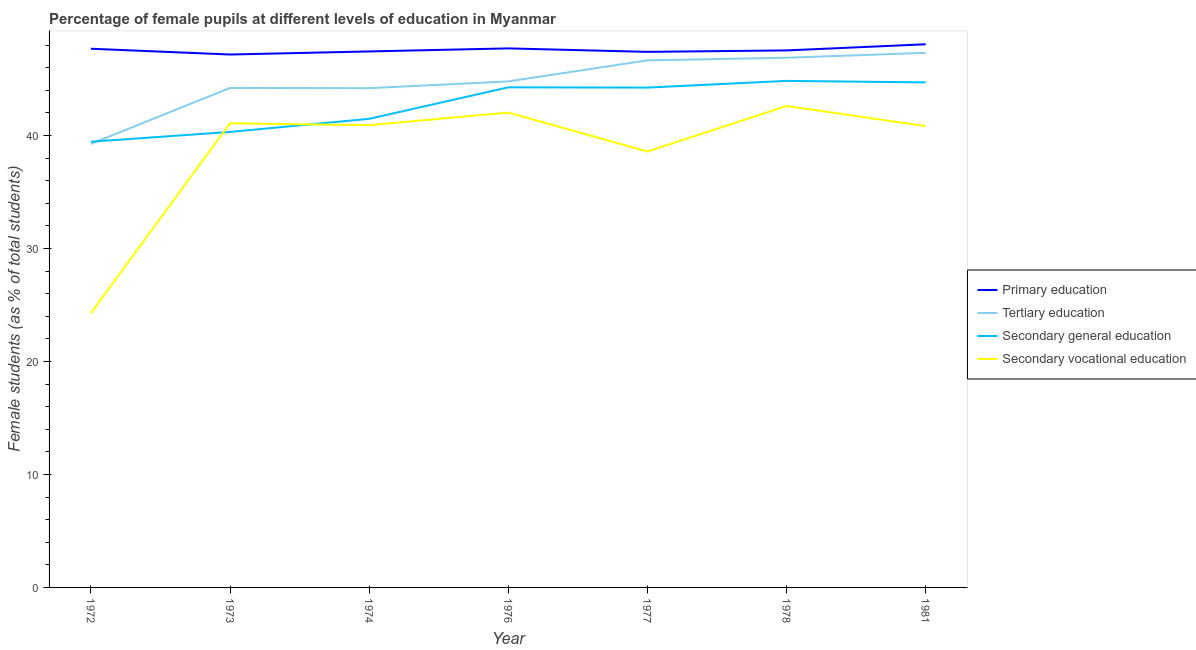How many different coloured lines are there?
Ensure brevity in your answer.  4. What is the percentage of female students in secondary vocational education in 1977?
Give a very brief answer. 38.58. Across all years, what is the maximum percentage of female students in secondary vocational education?
Make the answer very short. 42.61. Across all years, what is the minimum percentage of female students in secondary education?
Give a very brief answer. 39.45. In which year was the percentage of female students in primary education maximum?
Your response must be concise. 1981. In which year was the percentage of female students in secondary vocational education minimum?
Make the answer very short. 1972. What is the total percentage of female students in primary education in the graph?
Make the answer very short. 332.97. What is the difference between the percentage of female students in secondary vocational education in 1973 and that in 1977?
Offer a very short reply. 2.5. What is the difference between the percentage of female students in secondary vocational education in 1981 and the percentage of female students in secondary education in 1972?
Offer a terse response. 1.38. What is the average percentage of female students in primary education per year?
Ensure brevity in your answer.  47.57. In the year 1972, what is the difference between the percentage of female students in secondary vocational education and percentage of female students in tertiary education?
Offer a terse response. -14.98. What is the ratio of the percentage of female students in primary education in 1977 to that in 1978?
Ensure brevity in your answer.  1. Is the percentage of female students in primary education in 1976 less than that in 1977?
Provide a short and direct response. No. What is the difference between the highest and the second highest percentage of female students in secondary vocational education?
Your answer should be compact. 0.58. What is the difference between the highest and the lowest percentage of female students in secondary education?
Offer a very short reply. 5.38. In how many years, is the percentage of female students in secondary vocational education greater than the average percentage of female students in secondary vocational education taken over all years?
Give a very brief answer. 5. Is it the case that in every year, the sum of the percentage of female students in secondary education and percentage of female students in primary education is greater than the sum of percentage of female students in tertiary education and percentage of female students in secondary vocational education?
Provide a short and direct response. Yes. Is it the case that in every year, the sum of the percentage of female students in primary education and percentage of female students in tertiary education is greater than the percentage of female students in secondary education?
Your response must be concise. Yes. How many lines are there?
Give a very brief answer. 4. Does the graph contain any zero values?
Provide a short and direct response. No. Where does the legend appear in the graph?
Keep it short and to the point. Center right. How are the legend labels stacked?
Offer a terse response. Vertical. What is the title of the graph?
Your response must be concise. Percentage of female pupils at different levels of education in Myanmar. What is the label or title of the Y-axis?
Offer a terse response. Female students (as % of total students). What is the Female students (as % of total students) of Primary education in 1972?
Offer a terse response. 47.67. What is the Female students (as % of total students) of Tertiary education in 1972?
Offer a very short reply. 39.25. What is the Female students (as % of total students) of Secondary general education in 1972?
Provide a succinct answer. 39.45. What is the Female students (as % of total students) of Secondary vocational education in 1972?
Make the answer very short. 24.27. What is the Female students (as % of total students) in Primary education in 1973?
Your answer should be compact. 47.16. What is the Female students (as % of total students) of Tertiary education in 1973?
Your answer should be compact. 44.2. What is the Female students (as % of total students) of Secondary general education in 1973?
Your answer should be compact. 40.31. What is the Female students (as % of total students) of Secondary vocational education in 1973?
Provide a short and direct response. 41.08. What is the Female students (as % of total students) of Primary education in 1974?
Make the answer very short. 47.44. What is the Female students (as % of total students) of Tertiary education in 1974?
Ensure brevity in your answer.  44.18. What is the Female students (as % of total students) of Secondary general education in 1974?
Make the answer very short. 41.47. What is the Female students (as % of total students) in Secondary vocational education in 1974?
Your response must be concise. 40.91. What is the Female students (as % of total students) in Primary education in 1976?
Provide a short and direct response. 47.7. What is the Female students (as % of total students) in Tertiary education in 1976?
Your response must be concise. 44.78. What is the Female students (as % of total students) of Secondary general education in 1976?
Offer a very short reply. 44.26. What is the Female students (as % of total students) of Secondary vocational education in 1976?
Your response must be concise. 42.03. What is the Female students (as % of total students) in Primary education in 1977?
Keep it short and to the point. 47.4. What is the Female students (as % of total students) in Tertiary education in 1977?
Provide a short and direct response. 46.65. What is the Female students (as % of total students) in Secondary general education in 1977?
Your answer should be very brief. 44.24. What is the Female students (as % of total students) of Secondary vocational education in 1977?
Keep it short and to the point. 38.58. What is the Female students (as % of total students) of Primary education in 1978?
Provide a succinct answer. 47.53. What is the Female students (as % of total students) in Tertiary education in 1978?
Your response must be concise. 46.87. What is the Female students (as % of total students) in Secondary general education in 1978?
Provide a short and direct response. 44.83. What is the Female students (as % of total students) of Secondary vocational education in 1978?
Offer a very short reply. 42.61. What is the Female students (as % of total students) of Primary education in 1981?
Your response must be concise. 48.07. What is the Female students (as % of total students) in Tertiary education in 1981?
Your answer should be very brief. 47.31. What is the Female students (as % of total students) in Secondary general education in 1981?
Give a very brief answer. 44.69. What is the Female students (as % of total students) in Secondary vocational education in 1981?
Your answer should be very brief. 40.83. Across all years, what is the maximum Female students (as % of total students) of Primary education?
Offer a terse response. 48.07. Across all years, what is the maximum Female students (as % of total students) in Tertiary education?
Provide a short and direct response. 47.31. Across all years, what is the maximum Female students (as % of total students) of Secondary general education?
Provide a succinct answer. 44.83. Across all years, what is the maximum Female students (as % of total students) of Secondary vocational education?
Your answer should be very brief. 42.61. Across all years, what is the minimum Female students (as % of total students) in Primary education?
Offer a terse response. 47.16. Across all years, what is the minimum Female students (as % of total students) in Tertiary education?
Provide a short and direct response. 39.25. Across all years, what is the minimum Female students (as % of total students) of Secondary general education?
Make the answer very short. 39.45. Across all years, what is the minimum Female students (as % of total students) of Secondary vocational education?
Make the answer very short. 24.27. What is the total Female students (as % of total students) in Primary education in the graph?
Ensure brevity in your answer.  332.97. What is the total Female students (as % of total students) of Tertiary education in the graph?
Your answer should be compact. 313.26. What is the total Female students (as % of total students) of Secondary general education in the graph?
Your answer should be very brief. 299.25. What is the total Female students (as % of total students) of Secondary vocational education in the graph?
Offer a terse response. 270.3. What is the difference between the Female students (as % of total students) of Primary education in 1972 and that in 1973?
Your response must be concise. 0.51. What is the difference between the Female students (as % of total students) in Tertiary education in 1972 and that in 1973?
Your answer should be very brief. -4.95. What is the difference between the Female students (as % of total students) of Secondary general education in 1972 and that in 1973?
Your answer should be compact. -0.86. What is the difference between the Female students (as % of total students) in Secondary vocational education in 1972 and that in 1973?
Offer a terse response. -16.81. What is the difference between the Female students (as % of total students) of Primary education in 1972 and that in 1974?
Your answer should be compact. 0.24. What is the difference between the Female students (as % of total students) in Tertiary education in 1972 and that in 1974?
Give a very brief answer. -4.93. What is the difference between the Female students (as % of total students) of Secondary general education in 1972 and that in 1974?
Your response must be concise. -2.02. What is the difference between the Female students (as % of total students) of Secondary vocational education in 1972 and that in 1974?
Provide a succinct answer. -16.64. What is the difference between the Female students (as % of total students) in Primary education in 1972 and that in 1976?
Keep it short and to the point. -0.03. What is the difference between the Female students (as % of total students) in Tertiary education in 1972 and that in 1976?
Give a very brief answer. -5.53. What is the difference between the Female students (as % of total students) of Secondary general education in 1972 and that in 1976?
Your answer should be very brief. -4.81. What is the difference between the Female students (as % of total students) in Secondary vocational education in 1972 and that in 1976?
Your response must be concise. -17.75. What is the difference between the Female students (as % of total students) in Primary education in 1972 and that in 1977?
Your answer should be very brief. 0.28. What is the difference between the Female students (as % of total students) of Tertiary education in 1972 and that in 1977?
Your response must be concise. -7.39. What is the difference between the Female students (as % of total students) of Secondary general education in 1972 and that in 1977?
Your answer should be very brief. -4.79. What is the difference between the Female students (as % of total students) of Secondary vocational education in 1972 and that in 1977?
Ensure brevity in your answer.  -14.31. What is the difference between the Female students (as % of total students) in Primary education in 1972 and that in 1978?
Ensure brevity in your answer.  0.15. What is the difference between the Female students (as % of total students) in Tertiary education in 1972 and that in 1978?
Keep it short and to the point. -7.62. What is the difference between the Female students (as % of total students) of Secondary general education in 1972 and that in 1978?
Keep it short and to the point. -5.38. What is the difference between the Female students (as % of total students) in Secondary vocational education in 1972 and that in 1978?
Keep it short and to the point. -18.33. What is the difference between the Female students (as % of total students) of Primary education in 1972 and that in 1981?
Your answer should be very brief. -0.4. What is the difference between the Female students (as % of total students) of Tertiary education in 1972 and that in 1981?
Provide a succinct answer. -8.06. What is the difference between the Female students (as % of total students) in Secondary general education in 1972 and that in 1981?
Your response must be concise. -5.25. What is the difference between the Female students (as % of total students) of Secondary vocational education in 1972 and that in 1981?
Your answer should be compact. -16.55. What is the difference between the Female students (as % of total students) in Primary education in 1973 and that in 1974?
Offer a very short reply. -0.27. What is the difference between the Female students (as % of total students) of Tertiary education in 1973 and that in 1974?
Provide a short and direct response. 0.02. What is the difference between the Female students (as % of total students) of Secondary general education in 1973 and that in 1974?
Provide a short and direct response. -1.16. What is the difference between the Female students (as % of total students) in Secondary vocational education in 1973 and that in 1974?
Provide a short and direct response. 0.17. What is the difference between the Female students (as % of total students) in Primary education in 1973 and that in 1976?
Provide a short and direct response. -0.54. What is the difference between the Female students (as % of total students) in Tertiary education in 1973 and that in 1976?
Your response must be concise. -0.58. What is the difference between the Female students (as % of total students) of Secondary general education in 1973 and that in 1976?
Keep it short and to the point. -3.95. What is the difference between the Female students (as % of total students) in Secondary vocational education in 1973 and that in 1976?
Keep it short and to the point. -0.95. What is the difference between the Female students (as % of total students) in Primary education in 1973 and that in 1977?
Your response must be concise. -0.24. What is the difference between the Female students (as % of total students) of Tertiary education in 1973 and that in 1977?
Your answer should be very brief. -2.44. What is the difference between the Female students (as % of total students) in Secondary general education in 1973 and that in 1977?
Provide a short and direct response. -3.93. What is the difference between the Female students (as % of total students) in Secondary vocational education in 1973 and that in 1977?
Provide a succinct answer. 2.5. What is the difference between the Female students (as % of total students) in Primary education in 1973 and that in 1978?
Give a very brief answer. -0.36. What is the difference between the Female students (as % of total students) of Tertiary education in 1973 and that in 1978?
Your answer should be compact. -2.67. What is the difference between the Female students (as % of total students) in Secondary general education in 1973 and that in 1978?
Give a very brief answer. -4.52. What is the difference between the Female students (as % of total students) of Secondary vocational education in 1973 and that in 1978?
Give a very brief answer. -1.53. What is the difference between the Female students (as % of total students) of Primary education in 1973 and that in 1981?
Your response must be concise. -0.91. What is the difference between the Female students (as % of total students) of Tertiary education in 1973 and that in 1981?
Make the answer very short. -3.11. What is the difference between the Female students (as % of total students) of Secondary general education in 1973 and that in 1981?
Provide a short and direct response. -4.38. What is the difference between the Female students (as % of total students) in Secondary vocational education in 1973 and that in 1981?
Make the answer very short. 0.25. What is the difference between the Female students (as % of total students) in Primary education in 1974 and that in 1976?
Offer a very short reply. -0.27. What is the difference between the Female students (as % of total students) of Tertiary education in 1974 and that in 1976?
Your answer should be compact. -0.6. What is the difference between the Female students (as % of total students) in Secondary general education in 1974 and that in 1976?
Keep it short and to the point. -2.79. What is the difference between the Female students (as % of total students) of Secondary vocational education in 1974 and that in 1976?
Offer a terse response. -1.12. What is the difference between the Female students (as % of total students) in Primary education in 1974 and that in 1977?
Provide a succinct answer. 0.04. What is the difference between the Female students (as % of total students) in Tertiary education in 1974 and that in 1977?
Make the answer very short. -2.46. What is the difference between the Female students (as % of total students) of Secondary general education in 1974 and that in 1977?
Provide a succinct answer. -2.77. What is the difference between the Female students (as % of total students) in Secondary vocational education in 1974 and that in 1977?
Ensure brevity in your answer.  2.33. What is the difference between the Female students (as % of total students) of Primary education in 1974 and that in 1978?
Ensure brevity in your answer.  -0.09. What is the difference between the Female students (as % of total students) of Tertiary education in 1974 and that in 1978?
Make the answer very short. -2.69. What is the difference between the Female students (as % of total students) of Secondary general education in 1974 and that in 1978?
Provide a succinct answer. -3.36. What is the difference between the Female students (as % of total students) in Secondary vocational education in 1974 and that in 1978?
Offer a terse response. -1.7. What is the difference between the Female students (as % of total students) in Primary education in 1974 and that in 1981?
Keep it short and to the point. -0.63. What is the difference between the Female students (as % of total students) in Tertiary education in 1974 and that in 1981?
Your response must be concise. -3.13. What is the difference between the Female students (as % of total students) of Secondary general education in 1974 and that in 1981?
Ensure brevity in your answer.  -3.22. What is the difference between the Female students (as % of total students) of Secondary vocational education in 1974 and that in 1981?
Your response must be concise. 0.08. What is the difference between the Female students (as % of total students) of Primary education in 1976 and that in 1977?
Give a very brief answer. 0.31. What is the difference between the Female students (as % of total students) of Tertiary education in 1976 and that in 1977?
Give a very brief answer. -1.86. What is the difference between the Female students (as % of total students) in Secondary general education in 1976 and that in 1977?
Give a very brief answer. 0.02. What is the difference between the Female students (as % of total students) in Secondary vocational education in 1976 and that in 1977?
Keep it short and to the point. 3.45. What is the difference between the Female students (as % of total students) of Primary education in 1976 and that in 1978?
Ensure brevity in your answer.  0.18. What is the difference between the Female students (as % of total students) of Tertiary education in 1976 and that in 1978?
Give a very brief answer. -2.09. What is the difference between the Female students (as % of total students) of Secondary general education in 1976 and that in 1978?
Ensure brevity in your answer.  -0.57. What is the difference between the Female students (as % of total students) in Secondary vocational education in 1976 and that in 1978?
Provide a short and direct response. -0.58. What is the difference between the Female students (as % of total students) in Primary education in 1976 and that in 1981?
Your answer should be very brief. -0.37. What is the difference between the Female students (as % of total students) of Tertiary education in 1976 and that in 1981?
Ensure brevity in your answer.  -2.53. What is the difference between the Female students (as % of total students) in Secondary general education in 1976 and that in 1981?
Keep it short and to the point. -0.44. What is the difference between the Female students (as % of total students) of Secondary vocational education in 1976 and that in 1981?
Provide a short and direct response. 1.2. What is the difference between the Female students (as % of total students) in Primary education in 1977 and that in 1978?
Your answer should be very brief. -0.13. What is the difference between the Female students (as % of total students) in Tertiary education in 1977 and that in 1978?
Give a very brief answer. -0.23. What is the difference between the Female students (as % of total students) of Secondary general education in 1977 and that in 1978?
Provide a short and direct response. -0.59. What is the difference between the Female students (as % of total students) of Secondary vocational education in 1977 and that in 1978?
Provide a short and direct response. -4.03. What is the difference between the Female students (as % of total students) of Primary education in 1977 and that in 1981?
Your answer should be compact. -0.67. What is the difference between the Female students (as % of total students) in Tertiary education in 1977 and that in 1981?
Your response must be concise. -0.66. What is the difference between the Female students (as % of total students) of Secondary general education in 1977 and that in 1981?
Your answer should be very brief. -0.46. What is the difference between the Female students (as % of total students) of Secondary vocational education in 1977 and that in 1981?
Give a very brief answer. -2.25. What is the difference between the Female students (as % of total students) in Primary education in 1978 and that in 1981?
Offer a terse response. -0.54. What is the difference between the Female students (as % of total students) in Tertiary education in 1978 and that in 1981?
Ensure brevity in your answer.  -0.44. What is the difference between the Female students (as % of total students) of Secondary general education in 1978 and that in 1981?
Ensure brevity in your answer.  0.13. What is the difference between the Female students (as % of total students) in Secondary vocational education in 1978 and that in 1981?
Provide a succinct answer. 1.78. What is the difference between the Female students (as % of total students) in Primary education in 1972 and the Female students (as % of total students) in Tertiary education in 1973?
Provide a short and direct response. 3.47. What is the difference between the Female students (as % of total students) in Primary education in 1972 and the Female students (as % of total students) in Secondary general education in 1973?
Your answer should be compact. 7.36. What is the difference between the Female students (as % of total students) of Primary education in 1972 and the Female students (as % of total students) of Secondary vocational education in 1973?
Your answer should be very brief. 6.6. What is the difference between the Female students (as % of total students) in Tertiary education in 1972 and the Female students (as % of total students) in Secondary general education in 1973?
Ensure brevity in your answer.  -1.06. What is the difference between the Female students (as % of total students) in Tertiary education in 1972 and the Female students (as % of total students) in Secondary vocational education in 1973?
Provide a short and direct response. -1.83. What is the difference between the Female students (as % of total students) in Secondary general education in 1972 and the Female students (as % of total students) in Secondary vocational education in 1973?
Your response must be concise. -1.63. What is the difference between the Female students (as % of total students) in Primary education in 1972 and the Female students (as % of total students) in Tertiary education in 1974?
Provide a short and direct response. 3.49. What is the difference between the Female students (as % of total students) in Primary education in 1972 and the Female students (as % of total students) in Secondary general education in 1974?
Offer a very short reply. 6.2. What is the difference between the Female students (as % of total students) of Primary education in 1972 and the Female students (as % of total students) of Secondary vocational education in 1974?
Provide a short and direct response. 6.76. What is the difference between the Female students (as % of total students) in Tertiary education in 1972 and the Female students (as % of total students) in Secondary general education in 1974?
Offer a very short reply. -2.22. What is the difference between the Female students (as % of total students) of Tertiary education in 1972 and the Female students (as % of total students) of Secondary vocational education in 1974?
Your response must be concise. -1.66. What is the difference between the Female students (as % of total students) in Secondary general education in 1972 and the Female students (as % of total students) in Secondary vocational education in 1974?
Offer a terse response. -1.46. What is the difference between the Female students (as % of total students) in Primary education in 1972 and the Female students (as % of total students) in Tertiary education in 1976?
Ensure brevity in your answer.  2.89. What is the difference between the Female students (as % of total students) of Primary education in 1972 and the Female students (as % of total students) of Secondary general education in 1976?
Your answer should be very brief. 3.42. What is the difference between the Female students (as % of total students) of Primary education in 1972 and the Female students (as % of total students) of Secondary vocational education in 1976?
Offer a terse response. 5.65. What is the difference between the Female students (as % of total students) of Tertiary education in 1972 and the Female students (as % of total students) of Secondary general education in 1976?
Offer a terse response. -5. What is the difference between the Female students (as % of total students) of Tertiary education in 1972 and the Female students (as % of total students) of Secondary vocational education in 1976?
Your response must be concise. -2.77. What is the difference between the Female students (as % of total students) of Secondary general education in 1972 and the Female students (as % of total students) of Secondary vocational education in 1976?
Offer a terse response. -2.58. What is the difference between the Female students (as % of total students) in Primary education in 1972 and the Female students (as % of total students) in Tertiary education in 1977?
Keep it short and to the point. 1.03. What is the difference between the Female students (as % of total students) of Primary education in 1972 and the Female students (as % of total students) of Secondary general education in 1977?
Ensure brevity in your answer.  3.44. What is the difference between the Female students (as % of total students) in Primary education in 1972 and the Female students (as % of total students) in Secondary vocational education in 1977?
Offer a very short reply. 9.1. What is the difference between the Female students (as % of total students) of Tertiary education in 1972 and the Female students (as % of total students) of Secondary general education in 1977?
Ensure brevity in your answer.  -4.98. What is the difference between the Female students (as % of total students) of Tertiary education in 1972 and the Female students (as % of total students) of Secondary vocational education in 1977?
Your answer should be compact. 0.67. What is the difference between the Female students (as % of total students) in Secondary general education in 1972 and the Female students (as % of total students) in Secondary vocational education in 1977?
Your response must be concise. 0.87. What is the difference between the Female students (as % of total students) of Primary education in 1972 and the Female students (as % of total students) of Tertiary education in 1978?
Provide a succinct answer. 0.8. What is the difference between the Female students (as % of total students) in Primary education in 1972 and the Female students (as % of total students) in Secondary general education in 1978?
Provide a succinct answer. 2.85. What is the difference between the Female students (as % of total students) of Primary education in 1972 and the Female students (as % of total students) of Secondary vocational education in 1978?
Your answer should be compact. 5.07. What is the difference between the Female students (as % of total students) of Tertiary education in 1972 and the Female students (as % of total students) of Secondary general education in 1978?
Ensure brevity in your answer.  -5.58. What is the difference between the Female students (as % of total students) of Tertiary education in 1972 and the Female students (as % of total students) of Secondary vocational education in 1978?
Offer a very short reply. -3.35. What is the difference between the Female students (as % of total students) of Secondary general education in 1972 and the Female students (as % of total students) of Secondary vocational education in 1978?
Offer a terse response. -3.16. What is the difference between the Female students (as % of total students) of Primary education in 1972 and the Female students (as % of total students) of Tertiary education in 1981?
Make the answer very short. 0.36. What is the difference between the Female students (as % of total students) in Primary education in 1972 and the Female students (as % of total students) in Secondary general education in 1981?
Provide a short and direct response. 2.98. What is the difference between the Female students (as % of total students) of Primary education in 1972 and the Female students (as % of total students) of Secondary vocational education in 1981?
Ensure brevity in your answer.  6.85. What is the difference between the Female students (as % of total students) in Tertiary education in 1972 and the Female students (as % of total students) in Secondary general education in 1981?
Offer a terse response. -5.44. What is the difference between the Female students (as % of total students) in Tertiary education in 1972 and the Female students (as % of total students) in Secondary vocational education in 1981?
Keep it short and to the point. -1.57. What is the difference between the Female students (as % of total students) in Secondary general education in 1972 and the Female students (as % of total students) in Secondary vocational education in 1981?
Provide a short and direct response. -1.38. What is the difference between the Female students (as % of total students) in Primary education in 1973 and the Female students (as % of total students) in Tertiary education in 1974?
Offer a very short reply. 2.98. What is the difference between the Female students (as % of total students) of Primary education in 1973 and the Female students (as % of total students) of Secondary general education in 1974?
Your response must be concise. 5.69. What is the difference between the Female students (as % of total students) in Primary education in 1973 and the Female students (as % of total students) in Secondary vocational education in 1974?
Offer a very short reply. 6.25. What is the difference between the Female students (as % of total students) in Tertiary education in 1973 and the Female students (as % of total students) in Secondary general education in 1974?
Your answer should be compact. 2.73. What is the difference between the Female students (as % of total students) in Tertiary education in 1973 and the Female students (as % of total students) in Secondary vocational education in 1974?
Give a very brief answer. 3.29. What is the difference between the Female students (as % of total students) of Secondary general education in 1973 and the Female students (as % of total students) of Secondary vocational education in 1974?
Give a very brief answer. -0.6. What is the difference between the Female students (as % of total students) in Primary education in 1973 and the Female students (as % of total students) in Tertiary education in 1976?
Offer a very short reply. 2.38. What is the difference between the Female students (as % of total students) of Primary education in 1973 and the Female students (as % of total students) of Secondary general education in 1976?
Provide a succinct answer. 2.9. What is the difference between the Female students (as % of total students) of Primary education in 1973 and the Female students (as % of total students) of Secondary vocational education in 1976?
Provide a short and direct response. 5.14. What is the difference between the Female students (as % of total students) in Tertiary education in 1973 and the Female students (as % of total students) in Secondary general education in 1976?
Provide a short and direct response. -0.05. What is the difference between the Female students (as % of total students) of Tertiary education in 1973 and the Female students (as % of total students) of Secondary vocational education in 1976?
Provide a succinct answer. 2.18. What is the difference between the Female students (as % of total students) of Secondary general education in 1973 and the Female students (as % of total students) of Secondary vocational education in 1976?
Offer a terse response. -1.71. What is the difference between the Female students (as % of total students) of Primary education in 1973 and the Female students (as % of total students) of Tertiary education in 1977?
Your answer should be very brief. 0.52. What is the difference between the Female students (as % of total students) of Primary education in 1973 and the Female students (as % of total students) of Secondary general education in 1977?
Your answer should be compact. 2.93. What is the difference between the Female students (as % of total students) in Primary education in 1973 and the Female students (as % of total students) in Secondary vocational education in 1977?
Your response must be concise. 8.58. What is the difference between the Female students (as % of total students) of Tertiary education in 1973 and the Female students (as % of total students) of Secondary general education in 1977?
Ensure brevity in your answer.  -0.03. What is the difference between the Female students (as % of total students) of Tertiary education in 1973 and the Female students (as % of total students) of Secondary vocational education in 1977?
Offer a terse response. 5.63. What is the difference between the Female students (as % of total students) in Secondary general education in 1973 and the Female students (as % of total students) in Secondary vocational education in 1977?
Provide a short and direct response. 1.73. What is the difference between the Female students (as % of total students) of Primary education in 1973 and the Female students (as % of total students) of Tertiary education in 1978?
Make the answer very short. 0.29. What is the difference between the Female students (as % of total students) of Primary education in 1973 and the Female students (as % of total students) of Secondary general education in 1978?
Give a very brief answer. 2.33. What is the difference between the Female students (as % of total students) of Primary education in 1973 and the Female students (as % of total students) of Secondary vocational education in 1978?
Make the answer very short. 4.56. What is the difference between the Female students (as % of total students) of Tertiary education in 1973 and the Female students (as % of total students) of Secondary general education in 1978?
Provide a short and direct response. -0.62. What is the difference between the Female students (as % of total students) of Tertiary education in 1973 and the Female students (as % of total students) of Secondary vocational education in 1978?
Provide a succinct answer. 1.6. What is the difference between the Female students (as % of total students) in Secondary general education in 1973 and the Female students (as % of total students) in Secondary vocational education in 1978?
Ensure brevity in your answer.  -2.29. What is the difference between the Female students (as % of total students) of Primary education in 1973 and the Female students (as % of total students) of Tertiary education in 1981?
Your response must be concise. -0.15. What is the difference between the Female students (as % of total students) of Primary education in 1973 and the Female students (as % of total students) of Secondary general education in 1981?
Keep it short and to the point. 2.47. What is the difference between the Female students (as % of total students) in Primary education in 1973 and the Female students (as % of total students) in Secondary vocational education in 1981?
Your answer should be very brief. 6.34. What is the difference between the Female students (as % of total students) in Tertiary education in 1973 and the Female students (as % of total students) in Secondary general education in 1981?
Make the answer very short. -0.49. What is the difference between the Female students (as % of total students) in Tertiary education in 1973 and the Female students (as % of total students) in Secondary vocational education in 1981?
Provide a succinct answer. 3.38. What is the difference between the Female students (as % of total students) of Secondary general education in 1973 and the Female students (as % of total students) of Secondary vocational education in 1981?
Offer a very short reply. -0.52. What is the difference between the Female students (as % of total students) in Primary education in 1974 and the Female students (as % of total students) in Tertiary education in 1976?
Give a very brief answer. 2.65. What is the difference between the Female students (as % of total students) in Primary education in 1974 and the Female students (as % of total students) in Secondary general education in 1976?
Your answer should be compact. 3.18. What is the difference between the Female students (as % of total students) in Primary education in 1974 and the Female students (as % of total students) in Secondary vocational education in 1976?
Give a very brief answer. 5.41. What is the difference between the Female students (as % of total students) in Tertiary education in 1974 and the Female students (as % of total students) in Secondary general education in 1976?
Your response must be concise. -0.07. What is the difference between the Female students (as % of total students) of Tertiary education in 1974 and the Female students (as % of total students) of Secondary vocational education in 1976?
Your answer should be compact. 2.16. What is the difference between the Female students (as % of total students) in Secondary general education in 1974 and the Female students (as % of total students) in Secondary vocational education in 1976?
Your answer should be compact. -0.55. What is the difference between the Female students (as % of total students) in Primary education in 1974 and the Female students (as % of total students) in Tertiary education in 1977?
Offer a terse response. 0.79. What is the difference between the Female students (as % of total students) of Primary education in 1974 and the Female students (as % of total students) of Secondary general education in 1977?
Provide a short and direct response. 3.2. What is the difference between the Female students (as % of total students) of Primary education in 1974 and the Female students (as % of total students) of Secondary vocational education in 1977?
Your answer should be very brief. 8.86. What is the difference between the Female students (as % of total students) of Tertiary education in 1974 and the Female students (as % of total students) of Secondary general education in 1977?
Provide a succinct answer. -0.05. What is the difference between the Female students (as % of total students) of Tertiary education in 1974 and the Female students (as % of total students) of Secondary vocational education in 1977?
Give a very brief answer. 5.61. What is the difference between the Female students (as % of total students) of Secondary general education in 1974 and the Female students (as % of total students) of Secondary vocational education in 1977?
Provide a succinct answer. 2.89. What is the difference between the Female students (as % of total students) of Primary education in 1974 and the Female students (as % of total students) of Tertiary education in 1978?
Offer a terse response. 0.56. What is the difference between the Female students (as % of total students) of Primary education in 1974 and the Female students (as % of total students) of Secondary general education in 1978?
Offer a terse response. 2.61. What is the difference between the Female students (as % of total students) in Primary education in 1974 and the Female students (as % of total students) in Secondary vocational education in 1978?
Keep it short and to the point. 4.83. What is the difference between the Female students (as % of total students) in Tertiary education in 1974 and the Female students (as % of total students) in Secondary general education in 1978?
Provide a short and direct response. -0.65. What is the difference between the Female students (as % of total students) of Tertiary education in 1974 and the Female students (as % of total students) of Secondary vocational education in 1978?
Ensure brevity in your answer.  1.58. What is the difference between the Female students (as % of total students) of Secondary general education in 1974 and the Female students (as % of total students) of Secondary vocational education in 1978?
Your response must be concise. -1.13. What is the difference between the Female students (as % of total students) of Primary education in 1974 and the Female students (as % of total students) of Tertiary education in 1981?
Your answer should be compact. 0.12. What is the difference between the Female students (as % of total students) of Primary education in 1974 and the Female students (as % of total students) of Secondary general education in 1981?
Your answer should be compact. 2.74. What is the difference between the Female students (as % of total students) in Primary education in 1974 and the Female students (as % of total students) in Secondary vocational education in 1981?
Your answer should be very brief. 6.61. What is the difference between the Female students (as % of total students) in Tertiary education in 1974 and the Female students (as % of total students) in Secondary general education in 1981?
Keep it short and to the point. -0.51. What is the difference between the Female students (as % of total students) of Tertiary education in 1974 and the Female students (as % of total students) of Secondary vocational education in 1981?
Ensure brevity in your answer.  3.36. What is the difference between the Female students (as % of total students) of Secondary general education in 1974 and the Female students (as % of total students) of Secondary vocational education in 1981?
Provide a short and direct response. 0.64. What is the difference between the Female students (as % of total students) in Primary education in 1976 and the Female students (as % of total students) in Tertiary education in 1977?
Make the answer very short. 1.06. What is the difference between the Female students (as % of total students) of Primary education in 1976 and the Female students (as % of total students) of Secondary general education in 1977?
Offer a very short reply. 3.47. What is the difference between the Female students (as % of total students) in Primary education in 1976 and the Female students (as % of total students) in Secondary vocational education in 1977?
Keep it short and to the point. 9.13. What is the difference between the Female students (as % of total students) of Tertiary education in 1976 and the Female students (as % of total students) of Secondary general education in 1977?
Keep it short and to the point. 0.55. What is the difference between the Female students (as % of total students) in Tertiary education in 1976 and the Female students (as % of total students) in Secondary vocational education in 1977?
Ensure brevity in your answer.  6.2. What is the difference between the Female students (as % of total students) in Secondary general education in 1976 and the Female students (as % of total students) in Secondary vocational education in 1977?
Your answer should be very brief. 5.68. What is the difference between the Female students (as % of total students) of Primary education in 1976 and the Female students (as % of total students) of Tertiary education in 1978?
Offer a very short reply. 0.83. What is the difference between the Female students (as % of total students) in Primary education in 1976 and the Female students (as % of total students) in Secondary general education in 1978?
Offer a very short reply. 2.88. What is the difference between the Female students (as % of total students) in Primary education in 1976 and the Female students (as % of total students) in Secondary vocational education in 1978?
Your response must be concise. 5.1. What is the difference between the Female students (as % of total students) in Tertiary education in 1976 and the Female students (as % of total students) in Secondary general education in 1978?
Your answer should be very brief. -0.05. What is the difference between the Female students (as % of total students) in Tertiary education in 1976 and the Female students (as % of total students) in Secondary vocational education in 1978?
Provide a short and direct response. 2.18. What is the difference between the Female students (as % of total students) in Secondary general education in 1976 and the Female students (as % of total students) in Secondary vocational education in 1978?
Make the answer very short. 1.65. What is the difference between the Female students (as % of total students) in Primary education in 1976 and the Female students (as % of total students) in Tertiary education in 1981?
Offer a terse response. 0.39. What is the difference between the Female students (as % of total students) in Primary education in 1976 and the Female students (as % of total students) in Secondary general education in 1981?
Your answer should be very brief. 3.01. What is the difference between the Female students (as % of total students) of Primary education in 1976 and the Female students (as % of total students) of Secondary vocational education in 1981?
Offer a terse response. 6.88. What is the difference between the Female students (as % of total students) in Tertiary education in 1976 and the Female students (as % of total students) in Secondary general education in 1981?
Your answer should be compact. 0.09. What is the difference between the Female students (as % of total students) in Tertiary education in 1976 and the Female students (as % of total students) in Secondary vocational education in 1981?
Ensure brevity in your answer.  3.96. What is the difference between the Female students (as % of total students) in Secondary general education in 1976 and the Female students (as % of total students) in Secondary vocational education in 1981?
Your response must be concise. 3.43. What is the difference between the Female students (as % of total students) in Primary education in 1977 and the Female students (as % of total students) in Tertiary education in 1978?
Give a very brief answer. 0.52. What is the difference between the Female students (as % of total students) in Primary education in 1977 and the Female students (as % of total students) in Secondary general education in 1978?
Keep it short and to the point. 2.57. What is the difference between the Female students (as % of total students) in Primary education in 1977 and the Female students (as % of total students) in Secondary vocational education in 1978?
Offer a terse response. 4.79. What is the difference between the Female students (as % of total students) in Tertiary education in 1977 and the Female students (as % of total students) in Secondary general education in 1978?
Provide a short and direct response. 1.82. What is the difference between the Female students (as % of total students) of Tertiary education in 1977 and the Female students (as % of total students) of Secondary vocational education in 1978?
Your answer should be very brief. 4.04. What is the difference between the Female students (as % of total students) of Secondary general education in 1977 and the Female students (as % of total students) of Secondary vocational education in 1978?
Ensure brevity in your answer.  1.63. What is the difference between the Female students (as % of total students) of Primary education in 1977 and the Female students (as % of total students) of Tertiary education in 1981?
Give a very brief answer. 0.09. What is the difference between the Female students (as % of total students) of Primary education in 1977 and the Female students (as % of total students) of Secondary general education in 1981?
Your answer should be very brief. 2.7. What is the difference between the Female students (as % of total students) in Primary education in 1977 and the Female students (as % of total students) in Secondary vocational education in 1981?
Provide a succinct answer. 6.57. What is the difference between the Female students (as % of total students) in Tertiary education in 1977 and the Female students (as % of total students) in Secondary general education in 1981?
Offer a terse response. 1.95. What is the difference between the Female students (as % of total students) in Tertiary education in 1977 and the Female students (as % of total students) in Secondary vocational education in 1981?
Make the answer very short. 5.82. What is the difference between the Female students (as % of total students) in Secondary general education in 1977 and the Female students (as % of total students) in Secondary vocational education in 1981?
Offer a terse response. 3.41. What is the difference between the Female students (as % of total students) in Primary education in 1978 and the Female students (as % of total students) in Tertiary education in 1981?
Provide a short and direct response. 0.21. What is the difference between the Female students (as % of total students) in Primary education in 1978 and the Female students (as % of total students) in Secondary general education in 1981?
Provide a short and direct response. 2.83. What is the difference between the Female students (as % of total students) of Primary education in 1978 and the Female students (as % of total students) of Secondary vocational education in 1981?
Give a very brief answer. 6.7. What is the difference between the Female students (as % of total students) in Tertiary education in 1978 and the Female students (as % of total students) in Secondary general education in 1981?
Offer a terse response. 2.18. What is the difference between the Female students (as % of total students) in Tertiary education in 1978 and the Female students (as % of total students) in Secondary vocational education in 1981?
Offer a very short reply. 6.05. What is the difference between the Female students (as % of total students) in Secondary general education in 1978 and the Female students (as % of total students) in Secondary vocational education in 1981?
Give a very brief answer. 4. What is the average Female students (as % of total students) in Primary education per year?
Give a very brief answer. 47.57. What is the average Female students (as % of total students) in Tertiary education per year?
Your answer should be very brief. 44.75. What is the average Female students (as % of total students) in Secondary general education per year?
Your answer should be very brief. 42.75. What is the average Female students (as % of total students) in Secondary vocational education per year?
Provide a short and direct response. 38.61. In the year 1972, what is the difference between the Female students (as % of total students) of Primary education and Female students (as % of total students) of Tertiary education?
Provide a short and direct response. 8.42. In the year 1972, what is the difference between the Female students (as % of total students) of Primary education and Female students (as % of total students) of Secondary general education?
Your answer should be very brief. 8.23. In the year 1972, what is the difference between the Female students (as % of total students) of Primary education and Female students (as % of total students) of Secondary vocational education?
Your answer should be very brief. 23.4. In the year 1972, what is the difference between the Female students (as % of total students) in Tertiary education and Female students (as % of total students) in Secondary general education?
Make the answer very short. -0.19. In the year 1972, what is the difference between the Female students (as % of total students) in Tertiary education and Female students (as % of total students) in Secondary vocational education?
Offer a terse response. 14.98. In the year 1972, what is the difference between the Female students (as % of total students) in Secondary general education and Female students (as % of total students) in Secondary vocational education?
Provide a succinct answer. 15.18. In the year 1973, what is the difference between the Female students (as % of total students) in Primary education and Female students (as % of total students) in Tertiary education?
Make the answer very short. 2.96. In the year 1973, what is the difference between the Female students (as % of total students) of Primary education and Female students (as % of total students) of Secondary general education?
Your answer should be very brief. 6.85. In the year 1973, what is the difference between the Female students (as % of total students) of Primary education and Female students (as % of total students) of Secondary vocational education?
Offer a very short reply. 6.08. In the year 1973, what is the difference between the Female students (as % of total students) of Tertiary education and Female students (as % of total students) of Secondary general education?
Keep it short and to the point. 3.89. In the year 1973, what is the difference between the Female students (as % of total students) in Tertiary education and Female students (as % of total students) in Secondary vocational education?
Offer a terse response. 3.13. In the year 1973, what is the difference between the Female students (as % of total students) of Secondary general education and Female students (as % of total students) of Secondary vocational education?
Provide a succinct answer. -0.77. In the year 1974, what is the difference between the Female students (as % of total students) in Primary education and Female students (as % of total students) in Tertiary education?
Your answer should be compact. 3.25. In the year 1974, what is the difference between the Female students (as % of total students) in Primary education and Female students (as % of total students) in Secondary general education?
Offer a very short reply. 5.96. In the year 1974, what is the difference between the Female students (as % of total students) of Primary education and Female students (as % of total students) of Secondary vocational education?
Make the answer very short. 6.53. In the year 1974, what is the difference between the Female students (as % of total students) in Tertiary education and Female students (as % of total students) in Secondary general education?
Your answer should be compact. 2.71. In the year 1974, what is the difference between the Female students (as % of total students) in Tertiary education and Female students (as % of total students) in Secondary vocational education?
Your answer should be very brief. 3.27. In the year 1974, what is the difference between the Female students (as % of total students) of Secondary general education and Female students (as % of total students) of Secondary vocational education?
Offer a very short reply. 0.56. In the year 1976, what is the difference between the Female students (as % of total students) in Primary education and Female students (as % of total students) in Tertiary education?
Your answer should be compact. 2.92. In the year 1976, what is the difference between the Female students (as % of total students) in Primary education and Female students (as % of total students) in Secondary general education?
Give a very brief answer. 3.45. In the year 1976, what is the difference between the Female students (as % of total students) in Primary education and Female students (as % of total students) in Secondary vocational education?
Your answer should be very brief. 5.68. In the year 1976, what is the difference between the Female students (as % of total students) of Tertiary education and Female students (as % of total students) of Secondary general education?
Ensure brevity in your answer.  0.53. In the year 1976, what is the difference between the Female students (as % of total students) of Tertiary education and Female students (as % of total students) of Secondary vocational education?
Provide a short and direct response. 2.76. In the year 1976, what is the difference between the Female students (as % of total students) of Secondary general education and Female students (as % of total students) of Secondary vocational education?
Your answer should be compact. 2.23. In the year 1977, what is the difference between the Female students (as % of total students) in Primary education and Female students (as % of total students) in Tertiary education?
Provide a succinct answer. 0.75. In the year 1977, what is the difference between the Female students (as % of total students) in Primary education and Female students (as % of total students) in Secondary general education?
Give a very brief answer. 3.16. In the year 1977, what is the difference between the Female students (as % of total students) in Primary education and Female students (as % of total students) in Secondary vocational education?
Give a very brief answer. 8.82. In the year 1977, what is the difference between the Female students (as % of total students) of Tertiary education and Female students (as % of total students) of Secondary general education?
Keep it short and to the point. 2.41. In the year 1977, what is the difference between the Female students (as % of total students) of Tertiary education and Female students (as % of total students) of Secondary vocational education?
Give a very brief answer. 8.07. In the year 1977, what is the difference between the Female students (as % of total students) of Secondary general education and Female students (as % of total students) of Secondary vocational education?
Make the answer very short. 5.66. In the year 1978, what is the difference between the Female students (as % of total students) in Primary education and Female students (as % of total students) in Tertiary education?
Give a very brief answer. 0.65. In the year 1978, what is the difference between the Female students (as % of total students) in Primary education and Female students (as % of total students) in Secondary general education?
Provide a succinct answer. 2.7. In the year 1978, what is the difference between the Female students (as % of total students) of Primary education and Female students (as % of total students) of Secondary vocational education?
Give a very brief answer. 4.92. In the year 1978, what is the difference between the Female students (as % of total students) of Tertiary education and Female students (as % of total students) of Secondary general education?
Provide a succinct answer. 2.05. In the year 1978, what is the difference between the Female students (as % of total students) of Tertiary education and Female students (as % of total students) of Secondary vocational education?
Your answer should be compact. 4.27. In the year 1978, what is the difference between the Female students (as % of total students) of Secondary general education and Female students (as % of total students) of Secondary vocational education?
Provide a succinct answer. 2.22. In the year 1981, what is the difference between the Female students (as % of total students) in Primary education and Female students (as % of total students) in Tertiary education?
Give a very brief answer. 0.76. In the year 1981, what is the difference between the Female students (as % of total students) in Primary education and Female students (as % of total students) in Secondary general education?
Give a very brief answer. 3.38. In the year 1981, what is the difference between the Female students (as % of total students) in Primary education and Female students (as % of total students) in Secondary vocational education?
Offer a terse response. 7.24. In the year 1981, what is the difference between the Female students (as % of total students) of Tertiary education and Female students (as % of total students) of Secondary general education?
Make the answer very short. 2.62. In the year 1981, what is the difference between the Female students (as % of total students) in Tertiary education and Female students (as % of total students) in Secondary vocational education?
Provide a succinct answer. 6.48. In the year 1981, what is the difference between the Female students (as % of total students) of Secondary general education and Female students (as % of total students) of Secondary vocational education?
Offer a terse response. 3.87. What is the ratio of the Female students (as % of total students) in Primary education in 1972 to that in 1973?
Ensure brevity in your answer.  1.01. What is the ratio of the Female students (as % of total students) in Tertiary education in 1972 to that in 1973?
Your response must be concise. 0.89. What is the ratio of the Female students (as % of total students) of Secondary general education in 1972 to that in 1973?
Keep it short and to the point. 0.98. What is the ratio of the Female students (as % of total students) in Secondary vocational education in 1972 to that in 1973?
Provide a short and direct response. 0.59. What is the ratio of the Female students (as % of total students) of Primary education in 1972 to that in 1974?
Offer a very short reply. 1. What is the ratio of the Female students (as % of total students) of Tertiary education in 1972 to that in 1974?
Your answer should be compact. 0.89. What is the ratio of the Female students (as % of total students) of Secondary general education in 1972 to that in 1974?
Offer a very short reply. 0.95. What is the ratio of the Female students (as % of total students) of Secondary vocational education in 1972 to that in 1974?
Ensure brevity in your answer.  0.59. What is the ratio of the Female students (as % of total students) of Primary education in 1972 to that in 1976?
Your response must be concise. 1. What is the ratio of the Female students (as % of total students) in Tertiary education in 1972 to that in 1976?
Keep it short and to the point. 0.88. What is the ratio of the Female students (as % of total students) in Secondary general education in 1972 to that in 1976?
Offer a terse response. 0.89. What is the ratio of the Female students (as % of total students) in Secondary vocational education in 1972 to that in 1976?
Ensure brevity in your answer.  0.58. What is the ratio of the Female students (as % of total students) of Tertiary education in 1972 to that in 1977?
Give a very brief answer. 0.84. What is the ratio of the Female students (as % of total students) of Secondary general education in 1972 to that in 1977?
Your answer should be compact. 0.89. What is the ratio of the Female students (as % of total students) of Secondary vocational education in 1972 to that in 1977?
Your answer should be very brief. 0.63. What is the ratio of the Female students (as % of total students) of Tertiary education in 1972 to that in 1978?
Provide a short and direct response. 0.84. What is the ratio of the Female students (as % of total students) in Secondary vocational education in 1972 to that in 1978?
Provide a short and direct response. 0.57. What is the ratio of the Female students (as % of total students) of Primary education in 1972 to that in 1981?
Provide a short and direct response. 0.99. What is the ratio of the Female students (as % of total students) in Tertiary education in 1972 to that in 1981?
Make the answer very short. 0.83. What is the ratio of the Female students (as % of total students) in Secondary general education in 1972 to that in 1981?
Offer a very short reply. 0.88. What is the ratio of the Female students (as % of total students) in Secondary vocational education in 1972 to that in 1981?
Your answer should be compact. 0.59. What is the ratio of the Female students (as % of total students) of Tertiary education in 1973 to that in 1974?
Your answer should be very brief. 1. What is the ratio of the Female students (as % of total students) of Secondary general education in 1973 to that in 1974?
Offer a terse response. 0.97. What is the ratio of the Female students (as % of total students) in Secondary vocational education in 1973 to that in 1974?
Your answer should be compact. 1. What is the ratio of the Female students (as % of total students) in Primary education in 1973 to that in 1976?
Your answer should be compact. 0.99. What is the ratio of the Female students (as % of total students) of Tertiary education in 1973 to that in 1976?
Give a very brief answer. 0.99. What is the ratio of the Female students (as % of total students) of Secondary general education in 1973 to that in 1976?
Your response must be concise. 0.91. What is the ratio of the Female students (as % of total students) in Secondary vocational education in 1973 to that in 1976?
Your response must be concise. 0.98. What is the ratio of the Female students (as % of total students) in Primary education in 1973 to that in 1977?
Offer a very short reply. 0.99. What is the ratio of the Female students (as % of total students) in Tertiary education in 1973 to that in 1977?
Provide a succinct answer. 0.95. What is the ratio of the Female students (as % of total students) of Secondary general education in 1973 to that in 1977?
Provide a short and direct response. 0.91. What is the ratio of the Female students (as % of total students) of Secondary vocational education in 1973 to that in 1977?
Offer a terse response. 1.06. What is the ratio of the Female students (as % of total students) in Primary education in 1973 to that in 1978?
Your answer should be very brief. 0.99. What is the ratio of the Female students (as % of total students) in Tertiary education in 1973 to that in 1978?
Provide a short and direct response. 0.94. What is the ratio of the Female students (as % of total students) in Secondary general education in 1973 to that in 1978?
Your response must be concise. 0.9. What is the ratio of the Female students (as % of total students) of Secondary vocational education in 1973 to that in 1978?
Offer a terse response. 0.96. What is the ratio of the Female students (as % of total students) of Primary education in 1973 to that in 1981?
Your answer should be very brief. 0.98. What is the ratio of the Female students (as % of total students) of Tertiary education in 1973 to that in 1981?
Make the answer very short. 0.93. What is the ratio of the Female students (as % of total students) of Secondary general education in 1973 to that in 1981?
Your answer should be very brief. 0.9. What is the ratio of the Female students (as % of total students) of Primary education in 1974 to that in 1976?
Offer a terse response. 0.99. What is the ratio of the Female students (as % of total students) of Tertiary education in 1974 to that in 1976?
Your response must be concise. 0.99. What is the ratio of the Female students (as % of total students) of Secondary general education in 1974 to that in 1976?
Give a very brief answer. 0.94. What is the ratio of the Female students (as % of total students) in Secondary vocational education in 1974 to that in 1976?
Provide a succinct answer. 0.97. What is the ratio of the Female students (as % of total students) of Primary education in 1974 to that in 1977?
Your response must be concise. 1. What is the ratio of the Female students (as % of total students) of Tertiary education in 1974 to that in 1977?
Make the answer very short. 0.95. What is the ratio of the Female students (as % of total students) in Secondary general education in 1974 to that in 1977?
Your answer should be compact. 0.94. What is the ratio of the Female students (as % of total students) of Secondary vocational education in 1974 to that in 1977?
Keep it short and to the point. 1.06. What is the ratio of the Female students (as % of total students) in Tertiary education in 1974 to that in 1978?
Make the answer very short. 0.94. What is the ratio of the Female students (as % of total students) of Secondary general education in 1974 to that in 1978?
Your response must be concise. 0.93. What is the ratio of the Female students (as % of total students) in Secondary vocational education in 1974 to that in 1978?
Provide a short and direct response. 0.96. What is the ratio of the Female students (as % of total students) in Tertiary education in 1974 to that in 1981?
Provide a short and direct response. 0.93. What is the ratio of the Female students (as % of total students) in Secondary general education in 1974 to that in 1981?
Offer a very short reply. 0.93. What is the ratio of the Female students (as % of total students) in Primary education in 1976 to that in 1977?
Make the answer very short. 1.01. What is the ratio of the Female students (as % of total students) of Tertiary education in 1976 to that in 1977?
Give a very brief answer. 0.96. What is the ratio of the Female students (as % of total students) in Secondary vocational education in 1976 to that in 1977?
Your response must be concise. 1.09. What is the ratio of the Female students (as % of total students) in Tertiary education in 1976 to that in 1978?
Your answer should be compact. 0.96. What is the ratio of the Female students (as % of total students) in Secondary general education in 1976 to that in 1978?
Your response must be concise. 0.99. What is the ratio of the Female students (as % of total students) in Secondary vocational education in 1976 to that in 1978?
Keep it short and to the point. 0.99. What is the ratio of the Female students (as % of total students) of Tertiary education in 1976 to that in 1981?
Ensure brevity in your answer.  0.95. What is the ratio of the Female students (as % of total students) of Secondary general education in 1976 to that in 1981?
Keep it short and to the point. 0.99. What is the ratio of the Female students (as % of total students) of Secondary vocational education in 1976 to that in 1981?
Make the answer very short. 1.03. What is the ratio of the Female students (as % of total students) in Primary education in 1977 to that in 1978?
Ensure brevity in your answer.  1. What is the ratio of the Female students (as % of total students) of Secondary general education in 1977 to that in 1978?
Your answer should be compact. 0.99. What is the ratio of the Female students (as % of total students) of Secondary vocational education in 1977 to that in 1978?
Ensure brevity in your answer.  0.91. What is the ratio of the Female students (as % of total students) of Primary education in 1977 to that in 1981?
Provide a short and direct response. 0.99. What is the ratio of the Female students (as % of total students) in Tertiary education in 1977 to that in 1981?
Keep it short and to the point. 0.99. What is the ratio of the Female students (as % of total students) of Secondary general education in 1977 to that in 1981?
Provide a short and direct response. 0.99. What is the ratio of the Female students (as % of total students) of Secondary vocational education in 1977 to that in 1981?
Your response must be concise. 0.94. What is the ratio of the Female students (as % of total students) in Primary education in 1978 to that in 1981?
Ensure brevity in your answer.  0.99. What is the ratio of the Female students (as % of total students) in Secondary general education in 1978 to that in 1981?
Your response must be concise. 1. What is the ratio of the Female students (as % of total students) in Secondary vocational education in 1978 to that in 1981?
Provide a succinct answer. 1.04. What is the difference between the highest and the second highest Female students (as % of total students) of Primary education?
Your response must be concise. 0.37. What is the difference between the highest and the second highest Female students (as % of total students) of Tertiary education?
Your response must be concise. 0.44. What is the difference between the highest and the second highest Female students (as % of total students) in Secondary general education?
Your answer should be compact. 0.13. What is the difference between the highest and the second highest Female students (as % of total students) in Secondary vocational education?
Give a very brief answer. 0.58. What is the difference between the highest and the lowest Female students (as % of total students) of Primary education?
Your answer should be very brief. 0.91. What is the difference between the highest and the lowest Female students (as % of total students) of Tertiary education?
Give a very brief answer. 8.06. What is the difference between the highest and the lowest Female students (as % of total students) of Secondary general education?
Your answer should be compact. 5.38. What is the difference between the highest and the lowest Female students (as % of total students) of Secondary vocational education?
Your response must be concise. 18.33. 